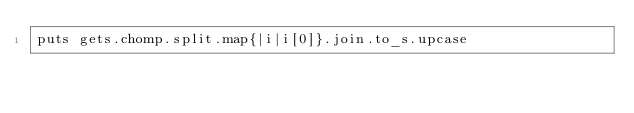Convert code to text. <code><loc_0><loc_0><loc_500><loc_500><_Ruby_>puts gets.chomp.split.map{|i|i[0]}.join.to_s.upcase</code> 